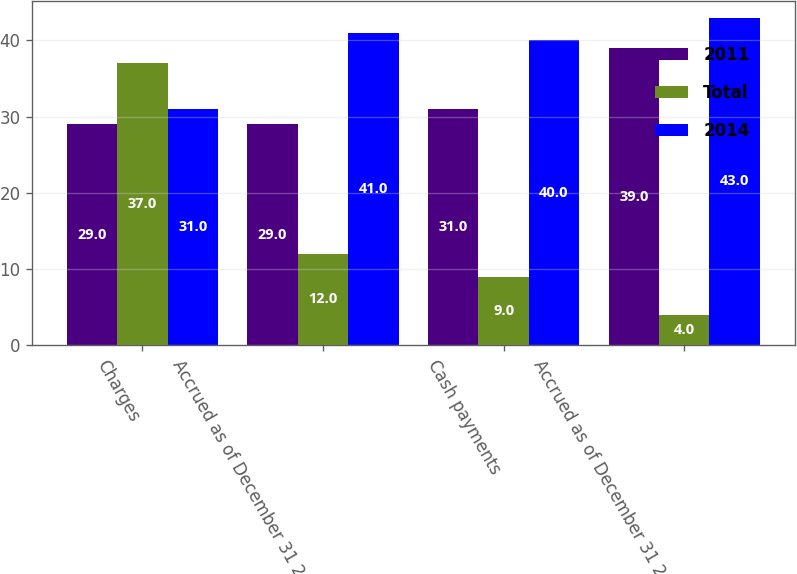Convert chart. <chart><loc_0><loc_0><loc_500><loc_500><stacked_bar_chart><ecel><fcel>Charges<fcel>Accrued as of December 31 2013<fcel>Cash payments<fcel>Accrued as of December 31 2014<nl><fcel>2011<fcel>29<fcel>29<fcel>31<fcel>39<nl><fcel>Total<fcel>37<fcel>12<fcel>9<fcel>4<nl><fcel>2014<fcel>31<fcel>41<fcel>40<fcel>43<nl></chart> 